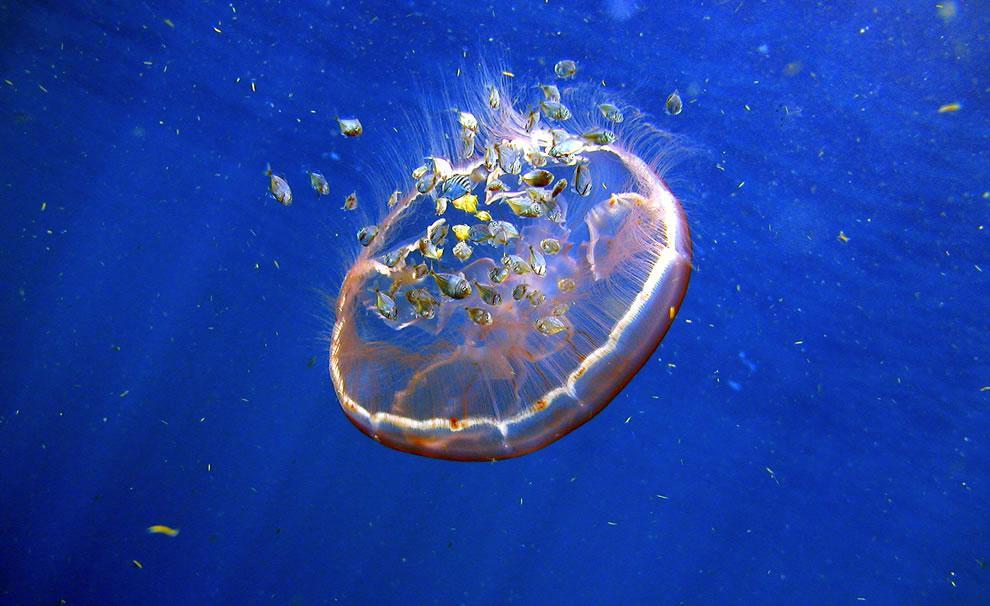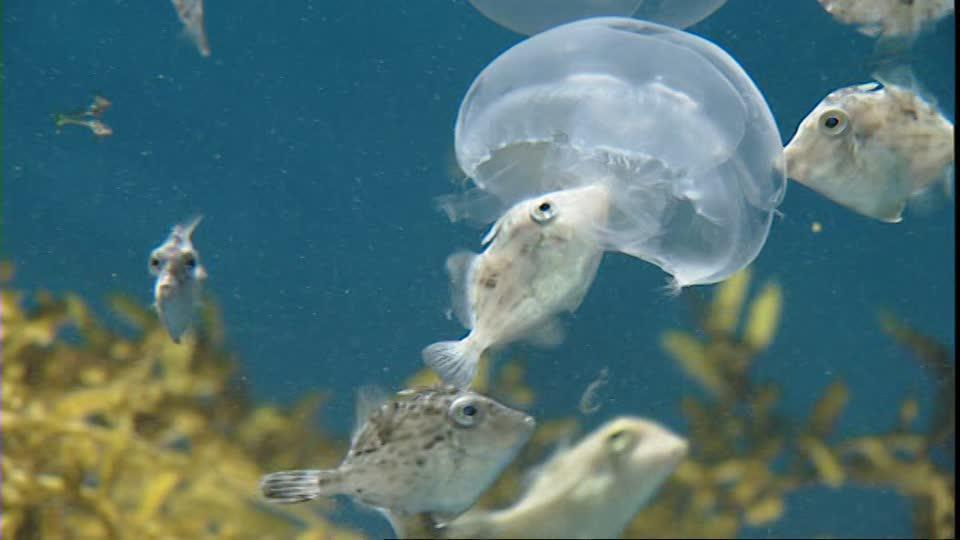The first image is the image on the left, the second image is the image on the right. Given the left and right images, does the statement "Left image shows one animal to the left of a violet-tinted jellyfish." hold true? Answer yes or no. No. 